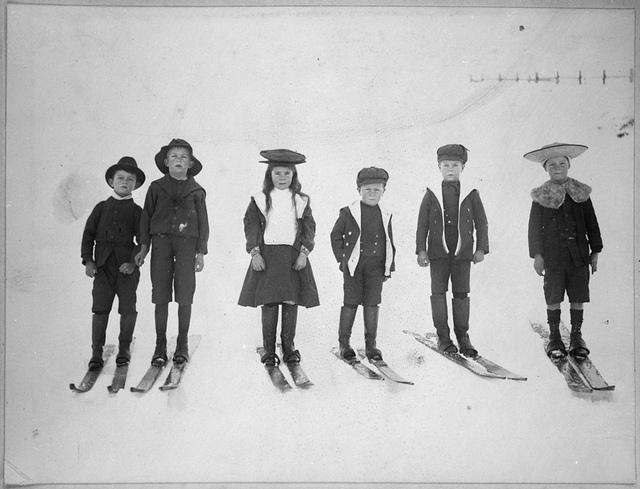How many children are in the picture?
Concise answer only. 6. Are these outfits for children?
Be succinct. Yes. Is this black and white?
Give a very brief answer. Yes. How many people are there?
Be succinct. 6. What is the approximate time period of this photo?
Answer briefly. 1900. 